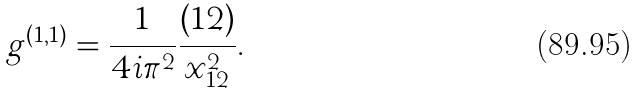<formula> <loc_0><loc_0><loc_500><loc_500>g ^ { ( 1 , 1 ) } = \frac { 1 } { 4 i \pi ^ { 2 } } \frac { ( 1 2 ) } { x _ { 1 2 } ^ { 2 } } .</formula> 